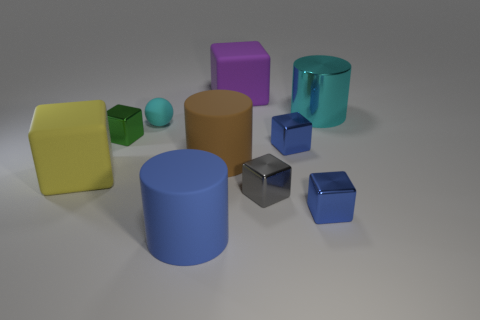What material is the green cube?
Offer a terse response. Metal. Are there any red matte cylinders?
Ensure brevity in your answer.  No. Are there the same number of large blocks that are in front of the purple block and small cyan matte spheres?
Keep it short and to the point. Yes. What number of large objects are rubber objects or cylinders?
Ensure brevity in your answer.  5. The matte thing that is the same color as the big metallic cylinder is what shape?
Offer a very short reply. Sphere. Is the material of the tiny thing on the left side of the tiny sphere the same as the gray thing?
Your answer should be very brief. Yes. There is a big block that is to the right of the large cylinder in front of the big brown object; what is its material?
Offer a very short reply. Rubber. What number of gray things are the same shape as the large yellow thing?
Provide a succinct answer. 1. There is a rubber block that is on the right side of the tiny thing behind the metal object left of the big purple thing; what size is it?
Ensure brevity in your answer.  Large. How many purple objects are large cubes or big shiny cylinders?
Provide a succinct answer. 1. 